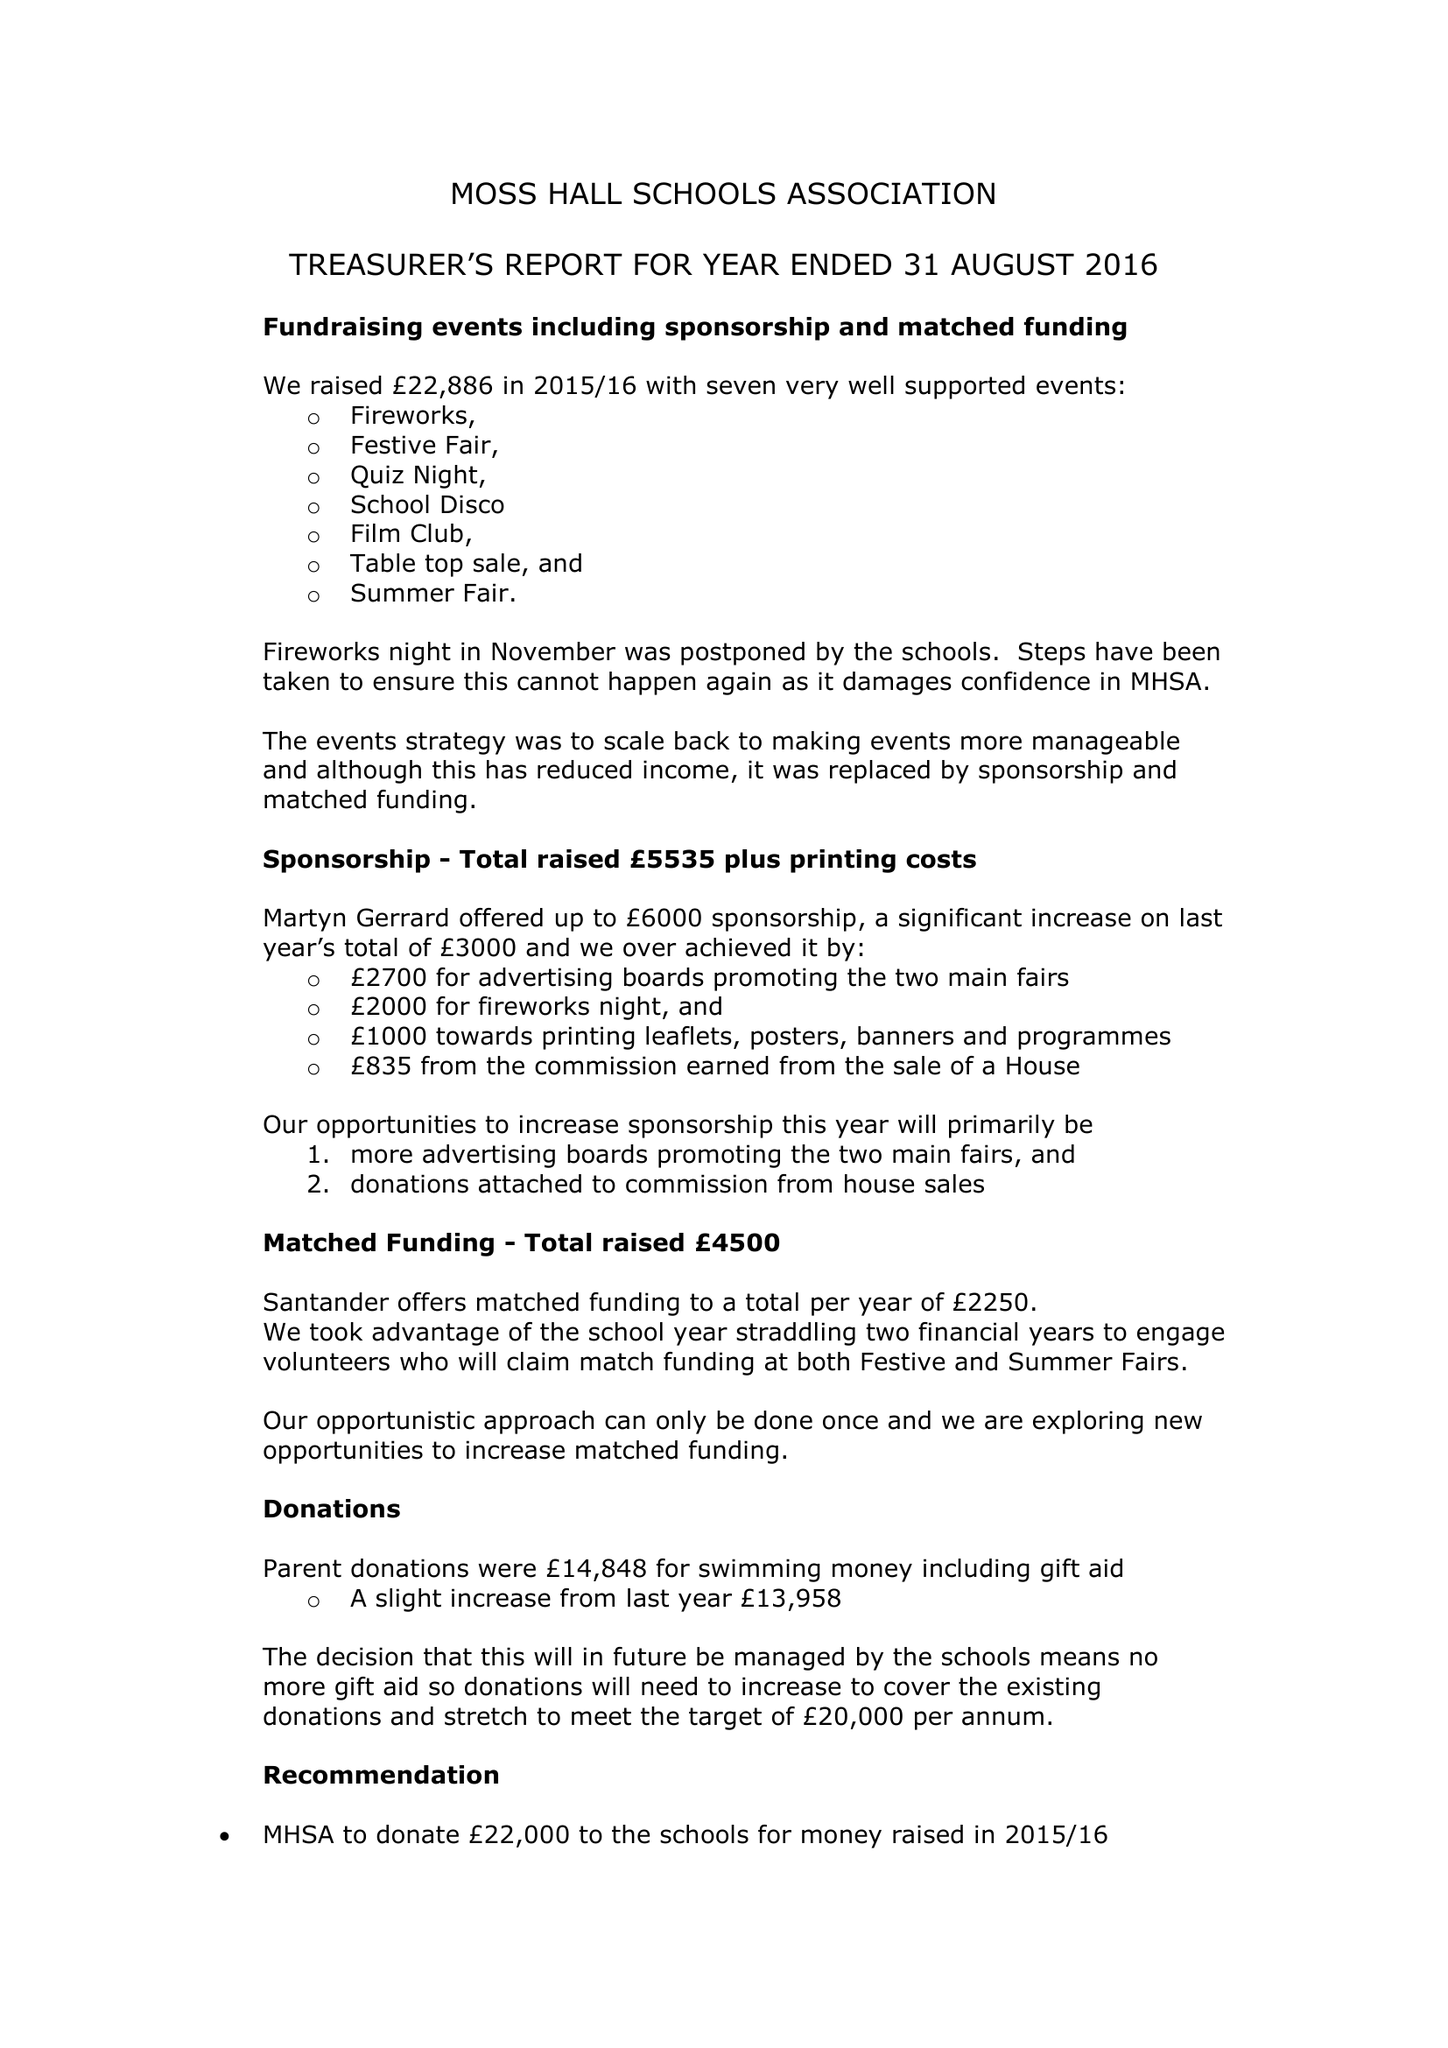What is the value for the address__post_town?
Answer the question using a single word or phrase. None 